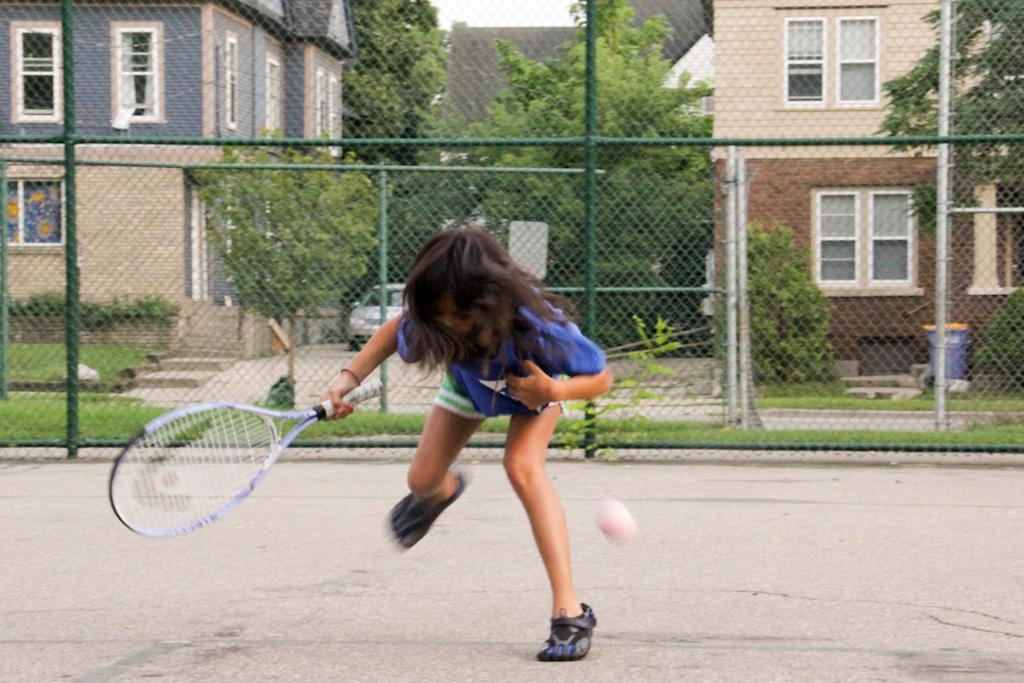In one or two sentences, can you explain what this image depicts? In this image there is a girl who is playing the tennis with the tennis bat. At the background there is a net through which we can see house,trees,windows,and grass. There is a ball beside her. 